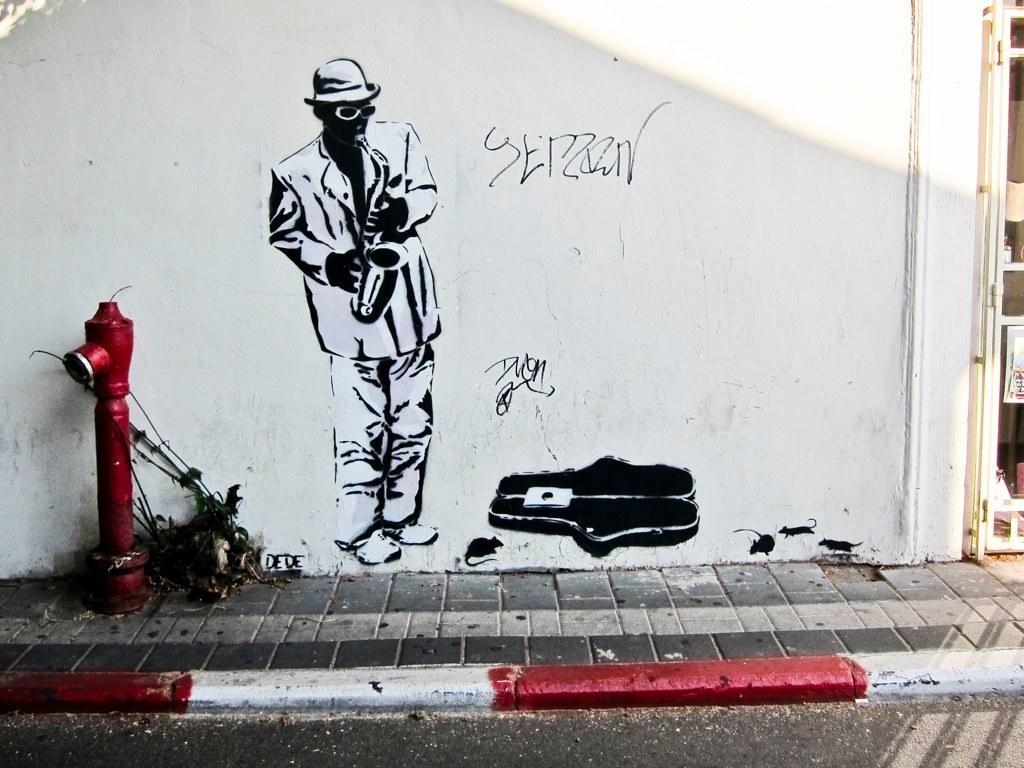Describe this image in one or two sentences. This is an outside view. At the bottom there is a road. Beside the road there is a footpath. On the left side there is a fire hydrant on the footpath. In the background there is a wall on which I can see a painting of a person who is holding a musical instrument and there is some text. On the the right side there is a door to the wall. 